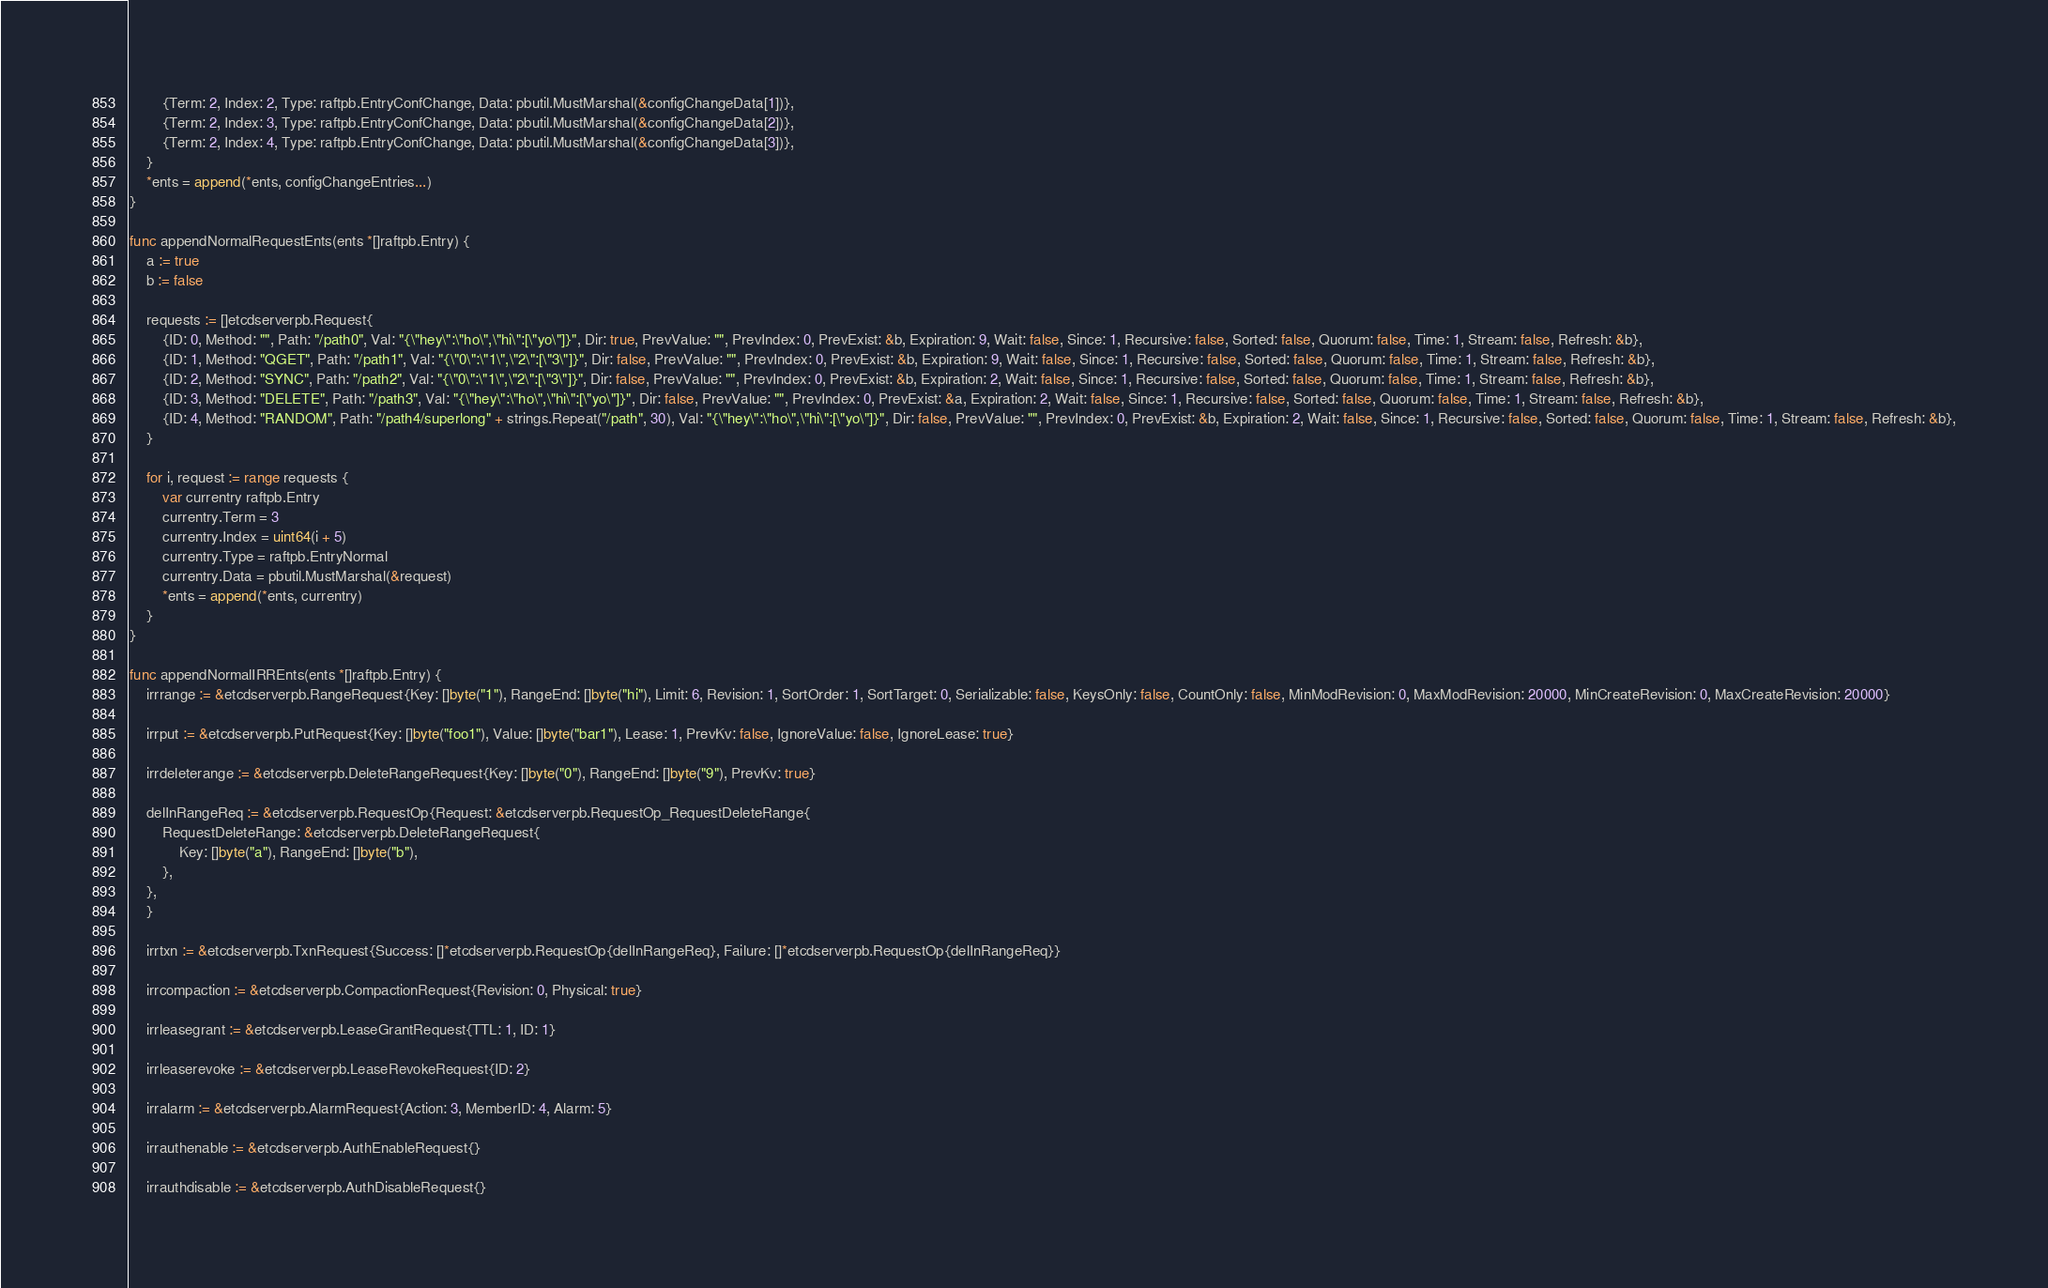Convert code to text. <code><loc_0><loc_0><loc_500><loc_500><_Go_>		{Term: 2, Index: 2, Type: raftpb.EntryConfChange, Data: pbutil.MustMarshal(&configChangeData[1])},
		{Term: 2, Index: 3, Type: raftpb.EntryConfChange, Data: pbutil.MustMarshal(&configChangeData[2])},
		{Term: 2, Index: 4, Type: raftpb.EntryConfChange, Data: pbutil.MustMarshal(&configChangeData[3])},
	}
	*ents = append(*ents, configChangeEntries...)
}

func appendNormalRequestEnts(ents *[]raftpb.Entry) {
	a := true
	b := false

	requests := []etcdserverpb.Request{
		{ID: 0, Method: "", Path: "/path0", Val: "{\"hey\":\"ho\",\"hi\":[\"yo\"]}", Dir: true, PrevValue: "", PrevIndex: 0, PrevExist: &b, Expiration: 9, Wait: false, Since: 1, Recursive: false, Sorted: false, Quorum: false, Time: 1, Stream: false, Refresh: &b},
		{ID: 1, Method: "QGET", Path: "/path1", Val: "{\"0\":\"1\",\"2\":[\"3\"]}", Dir: false, PrevValue: "", PrevIndex: 0, PrevExist: &b, Expiration: 9, Wait: false, Since: 1, Recursive: false, Sorted: false, Quorum: false, Time: 1, Stream: false, Refresh: &b},
		{ID: 2, Method: "SYNC", Path: "/path2", Val: "{\"0\":\"1\",\"2\":[\"3\"]}", Dir: false, PrevValue: "", PrevIndex: 0, PrevExist: &b, Expiration: 2, Wait: false, Since: 1, Recursive: false, Sorted: false, Quorum: false, Time: 1, Stream: false, Refresh: &b},
		{ID: 3, Method: "DELETE", Path: "/path3", Val: "{\"hey\":\"ho\",\"hi\":[\"yo\"]}", Dir: false, PrevValue: "", PrevIndex: 0, PrevExist: &a, Expiration: 2, Wait: false, Since: 1, Recursive: false, Sorted: false, Quorum: false, Time: 1, Stream: false, Refresh: &b},
		{ID: 4, Method: "RANDOM", Path: "/path4/superlong" + strings.Repeat("/path", 30), Val: "{\"hey\":\"ho\",\"hi\":[\"yo\"]}", Dir: false, PrevValue: "", PrevIndex: 0, PrevExist: &b, Expiration: 2, Wait: false, Since: 1, Recursive: false, Sorted: false, Quorum: false, Time: 1, Stream: false, Refresh: &b},
	}

	for i, request := range requests {
		var currentry raftpb.Entry
		currentry.Term = 3
		currentry.Index = uint64(i + 5)
		currentry.Type = raftpb.EntryNormal
		currentry.Data = pbutil.MustMarshal(&request)
		*ents = append(*ents, currentry)
	}
}

func appendNormalIRREnts(ents *[]raftpb.Entry) {
	irrrange := &etcdserverpb.RangeRequest{Key: []byte("1"), RangeEnd: []byte("hi"), Limit: 6, Revision: 1, SortOrder: 1, SortTarget: 0, Serializable: false, KeysOnly: false, CountOnly: false, MinModRevision: 0, MaxModRevision: 20000, MinCreateRevision: 0, MaxCreateRevision: 20000}

	irrput := &etcdserverpb.PutRequest{Key: []byte("foo1"), Value: []byte("bar1"), Lease: 1, PrevKv: false, IgnoreValue: false, IgnoreLease: true}

	irrdeleterange := &etcdserverpb.DeleteRangeRequest{Key: []byte("0"), RangeEnd: []byte("9"), PrevKv: true}

	delInRangeReq := &etcdserverpb.RequestOp{Request: &etcdserverpb.RequestOp_RequestDeleteRange{
		RequestDeleteRange: &etcdserverpb.DeleteRangeRequest{
			Key: []byte("a"), RangeEnd: []byte("b"),
		},
	},
	}

	irrtxn := &etcdserverpb.TxnRequest{Success: []*etcdserverpb.RequestOp{delInRangeReq}, Failure: []*etcdserverpb.RequestOp{delInRangeReq}}

	irrcompaction := &etcdserverpb.CompactionRequest{Revision: 0, Physical: true}

	irrleasegrant := &etcdserverpb.LeaseGrantRequest{TTL: 1, ID: 1}

	irrleaserevoke := &etcdserverpb.LeaseRevokeRequest{ID: 2}

	irralarm := &etcdserverpb.AlarmRequest{Action: 3, MemberID: 4, Alarm: 5}

	irrauthenable := &etcdserverpb.AuthEnableRequest{}

	irrauthdisable := &etcdserverpb.AuthDisableRequest{}
</code> 